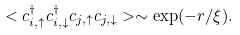<formula> <loc_0><loc_0><loc_500><loc_500>< c _ { i , \uparrow } ^ { \dagger } c _ { i , \downarrow } ^ { \dagger } c _ { j , \uparrow } c _ { j , \downarrow } > \sim \exp ( - r / \xi ) .</formula> 